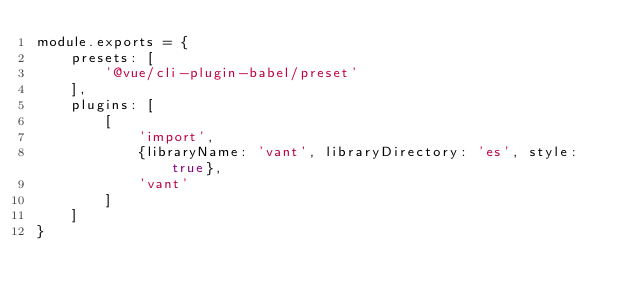<code> <loc_0><loc_0><loc_500><loc_500><_JavaScript_>module.exports = {
    presets: [
        '@vue/cli-plugin-babel/preset'
    ],
    plugins: [
        [
            'import',
            {libraryName: 'vant', libraryDirectory: 'es', style: true},
            'vant'
        ]
    ]
}
</code> 